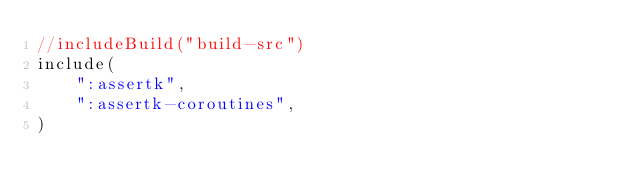Convert code to text. <code><loc_0><loc_0><loc_500><loc_500><_Kotlin_>//includeBuild("build-src")
include(
    ":assertk",
    ":assertk-coroutines",
)</code> 